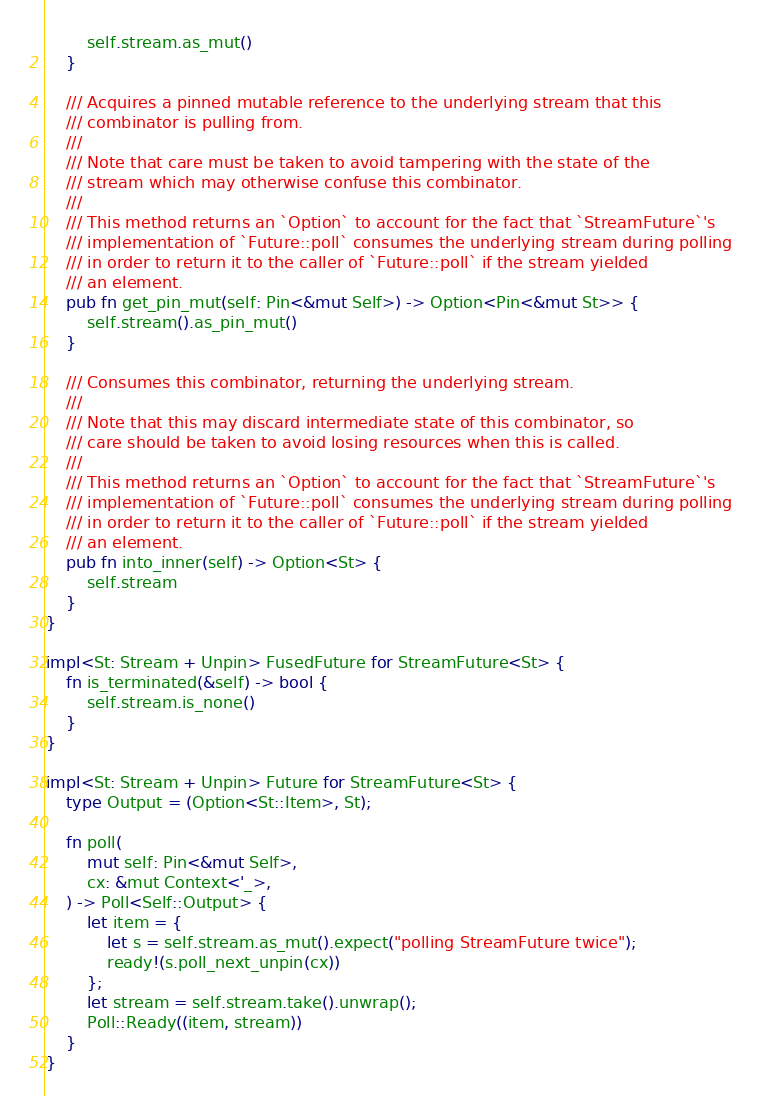Convert code to text. <code><loc_0><loc_0><loc_500><loc_500><_Rust_>        self.stream.as_mut()
    }

    /// Acquires a pinned mutable reference to the underlying stream that this
    /// combinator is pulling from.
    ///
    /// Note that care must be taken to avoid tampering with the state of the
    /// stream which may otherwise confuse this combinator.
    ///
    /// This method returns an `Option` to account for the fact that `StreamFuture`'s
    /// implementation of `Future::poll` consumes the underlying stream during polling
    /// in order to return it to the caller of `Future::poll` if the stream yielded
    /// an element.
    pub fn get_pin_mut(self: Pin<&mut Self>) -> Option<Pin<&mut St>> {
        self.stream().as_pin_mut()
    }

    /// Consumes this combinator, returning the underlying stream.
    ///
    /// Note that this may discard intermediate state of this combinator, so
    /// care should be taken to avoid losing resources when this is called.
    ///
    /// This method returns an `Option` to account for the fact that `StreamFuture`'s
    /// implementation of `Future::poll` consumes the underlying stream during polling
    /// in order to return it to the caller of `Future::poll` if the stream yielded
    /// an element.
    pub fn into_inner(self) -> Option<St> {
        self.stream
    }
}

impl<St: Stream + Unpin> FusedFuture for StreamFuture<St> {
    fn is_terminated(&self) -> bool {
        self.stream.is_none()
    }
}

impl<St: Stream + Unpin> Future for StreamFuture<St> {
    type Output = (Option<St::Item>, St);

    fn poll(
        mut self: Pin<&mut Self>,
        cx: &mut Context<'_>,
    ) -> Poll<Self::Output> {
        let item = {
            let s = self.stream.as_mut().expect("polling StreamFuture twice");
            ready!(s.poll_next_unpin(cx))
        };
        let stream = self.stream.take().unwrap();
        Poll::Ready((item, stream))
    }
}
</code> 